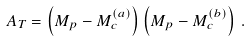Convert formula to latex. <formula><loc_0><loc_0><loc_500><loc_500>A _ { T } = \left ( M _ { p } - M _ { c } ^ { ( a ) } \right ) \left ( M _ { p } - M _ { c } ^ { ( b ) } \right ) \, .</formula> 